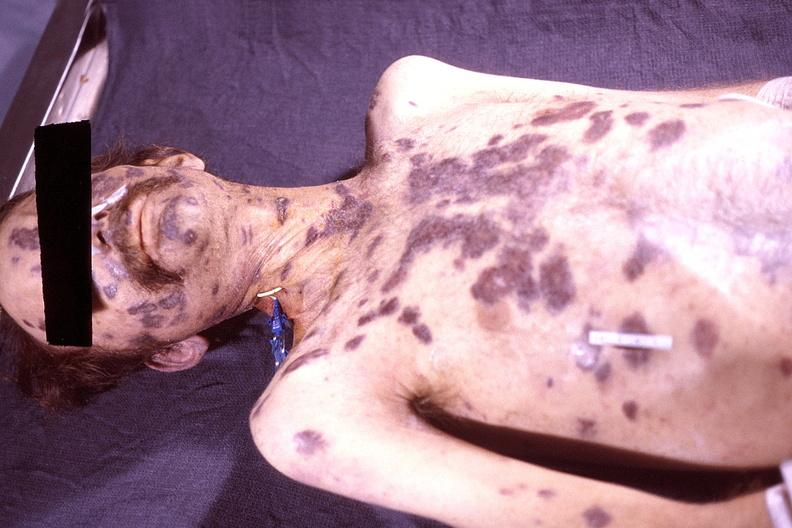does lesion of myocytolysis show skin, kaposis 's sarcoma?
Answer the question using a single word or phrase. No 